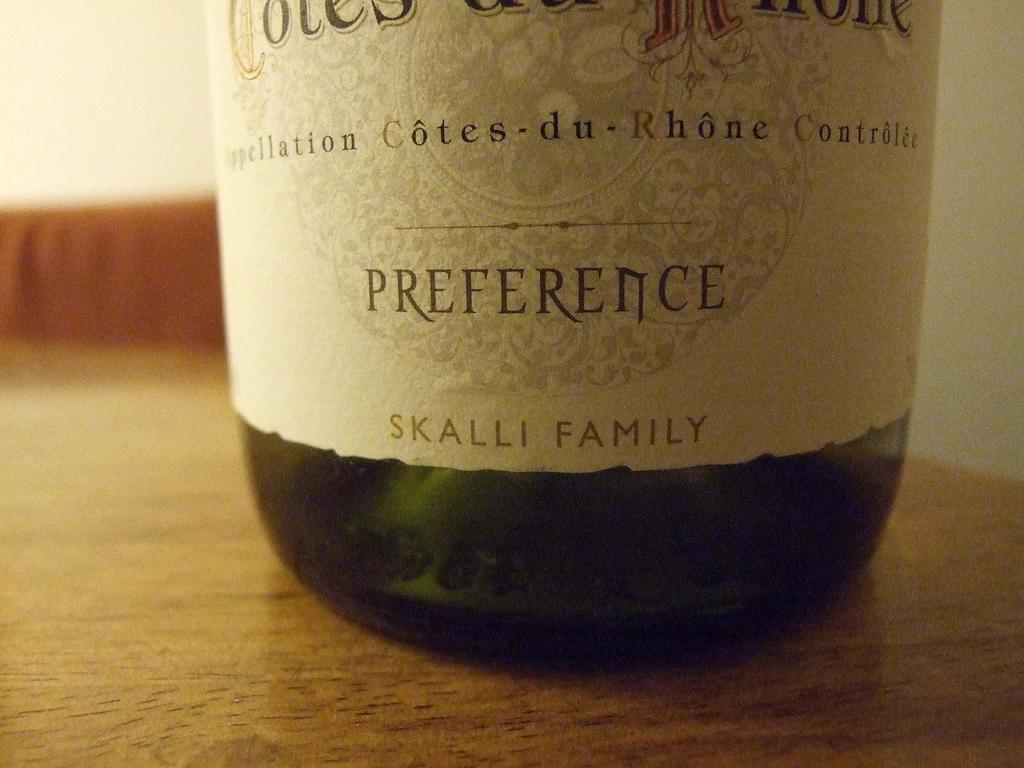<image>
Relay a brief, clear account of the picture shown. A bottle of wine by the Skalli family in  green glass. 